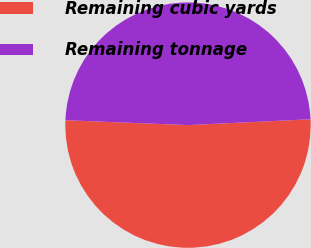<chart> <loc_0><loc_0><loc_500><loc_500><pie_chart><fcel>Remaining cubic yards<fcel>Remaining tonnage<nl><fcel>51.39%<fcel>48.61%<nl></chart> 